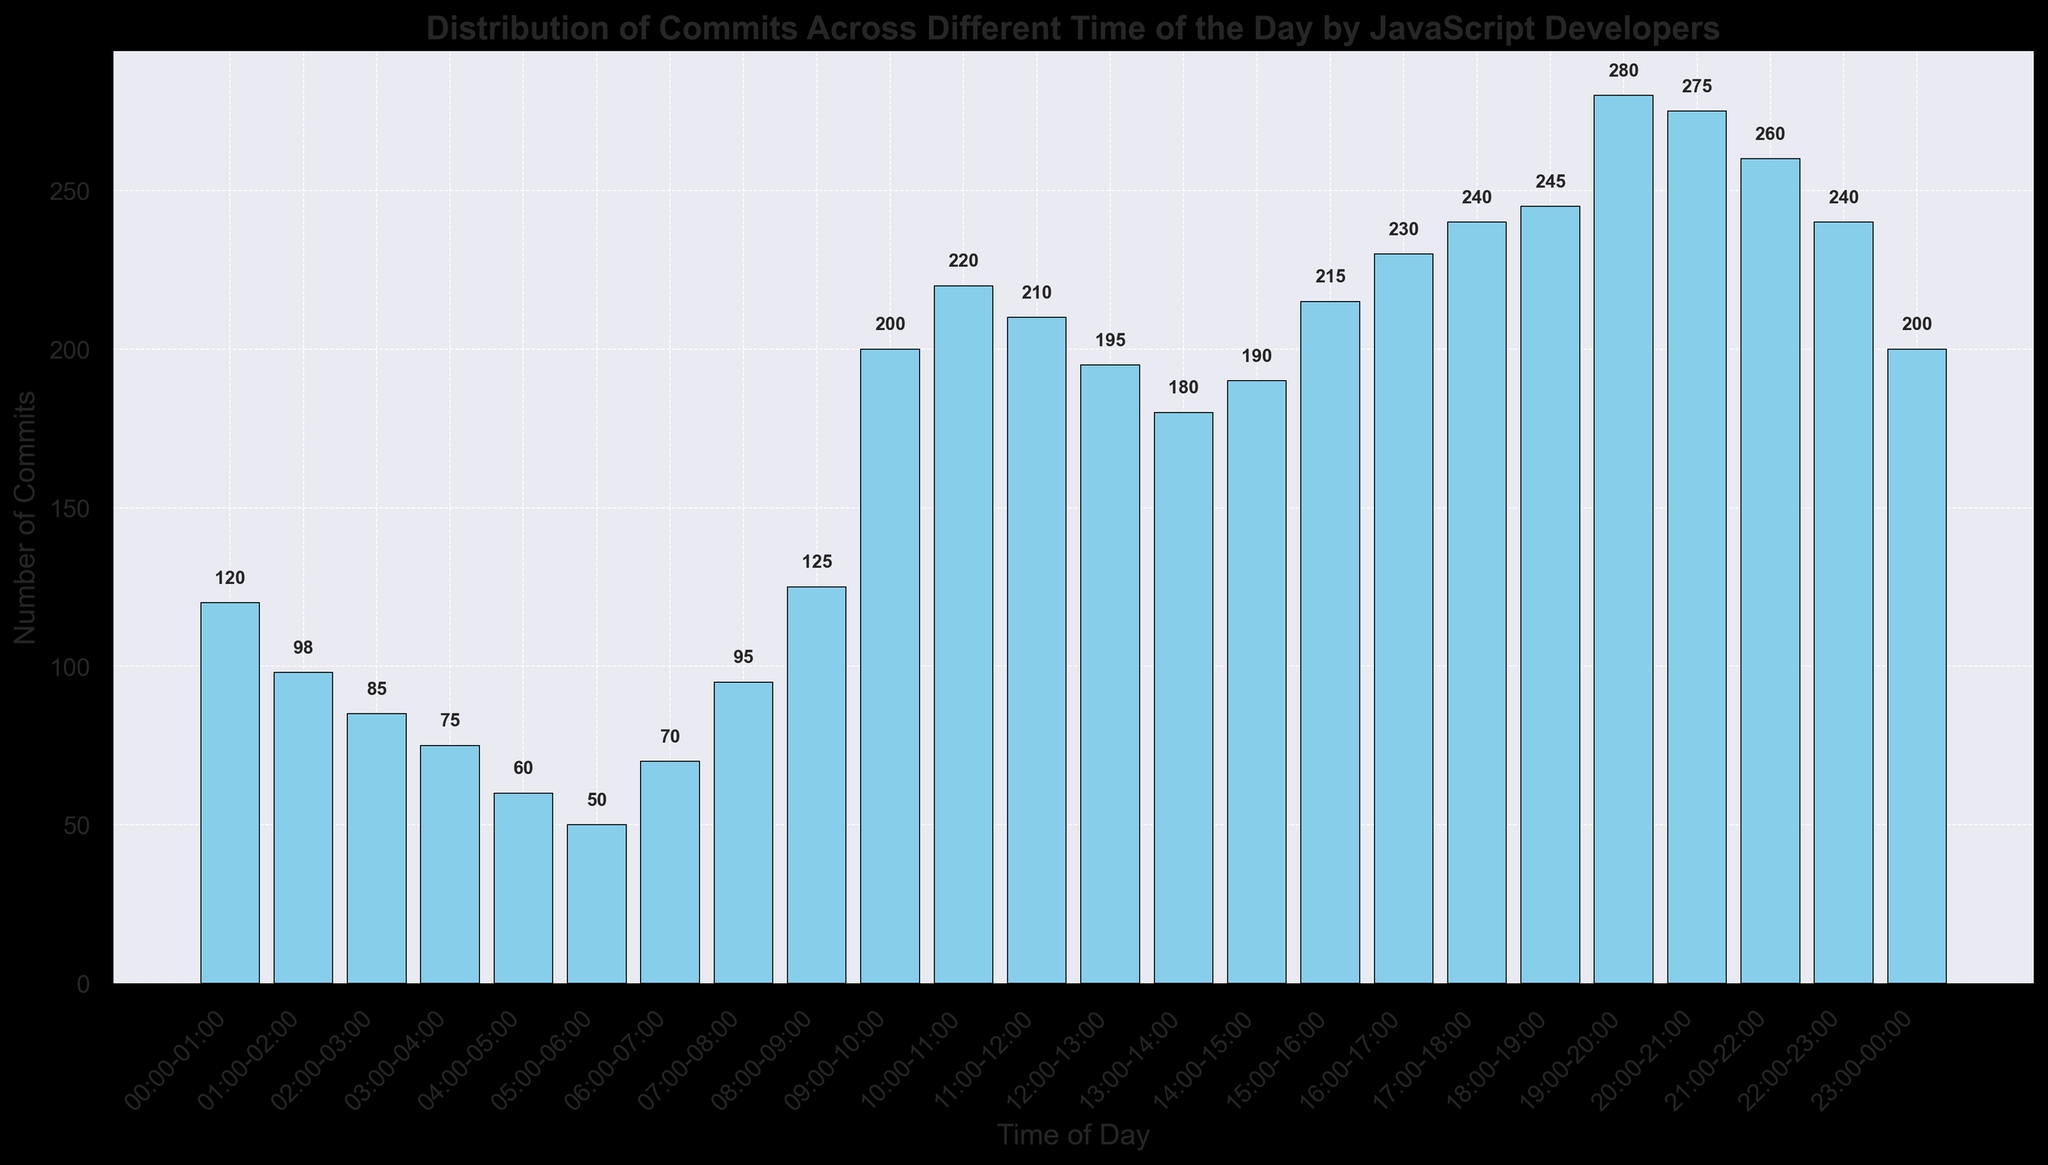What time of day has the highest number of commits? Visually, the bar for the 19:00-20:00 time slot is the tallest, indicating the highest number of commits.
Answer: 19:00-20:00 How many more commits are made between 19:00-20:00 and 04:00-05:00? The number of commits between 19:00-20:00 is 280, and between 04:00-05:00 is 60. Subtracting these gives 280 - 60 = 220.
Answer: 220 What is the total number of commits made during the first 4 hours of the day (00:00-04:00)? Adding the numbers for the first 4 hours: 120 (00:00-01:00) + 98 (01:00-02:00) + 85 (02:00-03:00) + 75 (03:00-04:00) = 378.
Answer: 378 During which hour do the number of commits first exceed 200? The bar for the 09:00-10:00 time slot first exceeds 200 commits.
Answer: 09:00-10:00 Which two consecutive hours have the greatest difference in the number of commits? Examining the data, the transition from 22:00-23:00 (240 commits) to 23:00-00:00 (200 commits) shows the largest drop (240 - 200 = 40).
Answer: 22:00-00:00 What is the average number of commits made between 16:00 and 20:00? Adding the commitments from 16:00-17:00 to 19:00-20:00 and dividing by the number of hours: (230 + 240 + 245 + 280) / 4 = 995 / 4 = 248.75.
Answer: 248.75 Does the number of commits increase steadily from midnight to noon? From the bar heights, the number of commits shows some fluctuations but overall increases towards noon. Specifically, some dips are observed around 01:00-05:00.
Answer: No How many commits are there between 07:00-08:00 and 08:00-09:00 combined? The commits for 07:00-08:00 are 95 and for 08:00-09:00 are 125. Summing these, 95 + 125 = 220.
Answer: 220 What's the difference in the number of commits between the peak hour and the hour with the fewest commits? The peak hour (19:00-20:00) has 280 commits, and the hour with the fewest commits (05:00-06:00) has 50. The difference is 280 - 50 = 230.
Answer: 230 